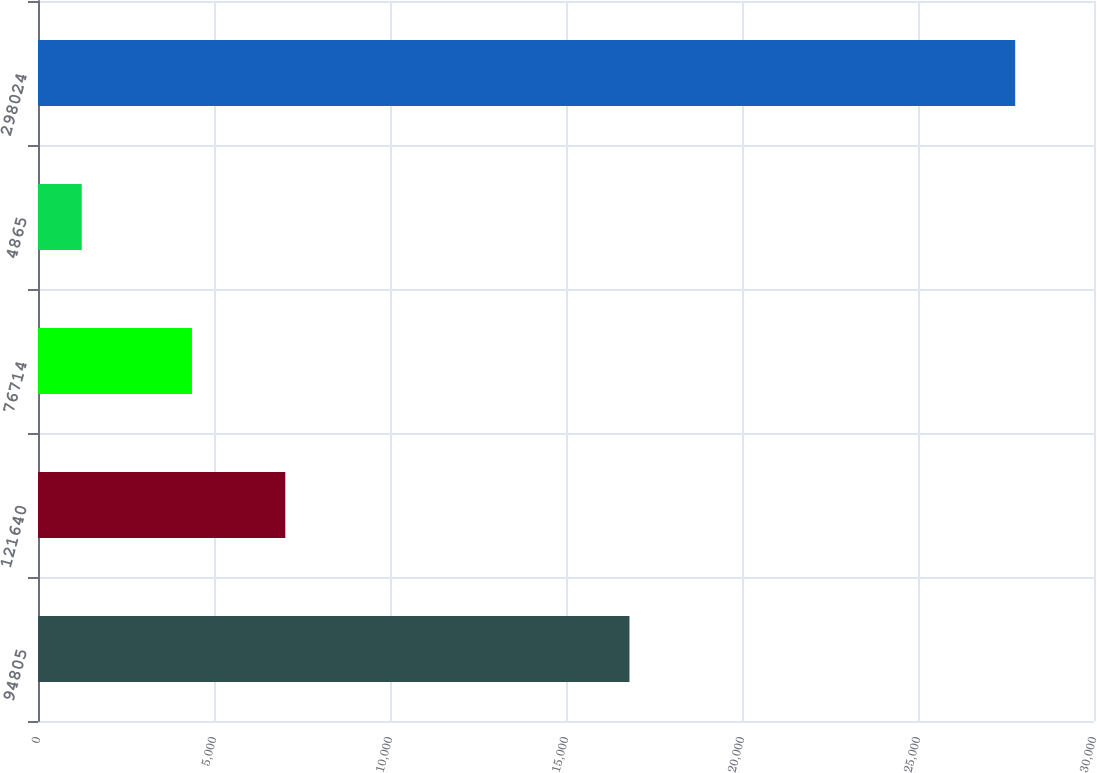Convert chart to OTSL. <chart><loc_0><loc_0><loc_500><loc_500><bar_chart><fcel>94805<fcel>121640<fcel>76714<fcel>4865<fcel>298024<nl><fcel>16803<fcel>7025.8<fcel>4374<fcel>1243<fcel>27761<nl></chart> 